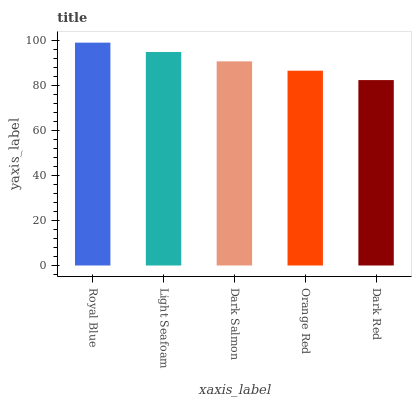Is Light Seafoam the minimum?
Answer yes or no. No. Is Light Seafoam the maximum?
Answer yes or no. No. Is Royal Blue greater than Light Seafoam?
Answer yes or no. Yes. Is Light Seafoam less than Royal Blue?
Answer yes or no. Yes. Is Light Seafoam greater than Royal Blue?
Answer yes or no. No. Is Royal Blue less than Light Seafoam?
Answer yes or no. No. Is Dark Salmon the high median?
Answer yes or no. Yes. Is Dark Salmon the low median?
Answer yes or no. Yes. Is Orange Red the high median?
Answer yes or no. No. Is Dark Red the low median?
Answer yes or no. No. 